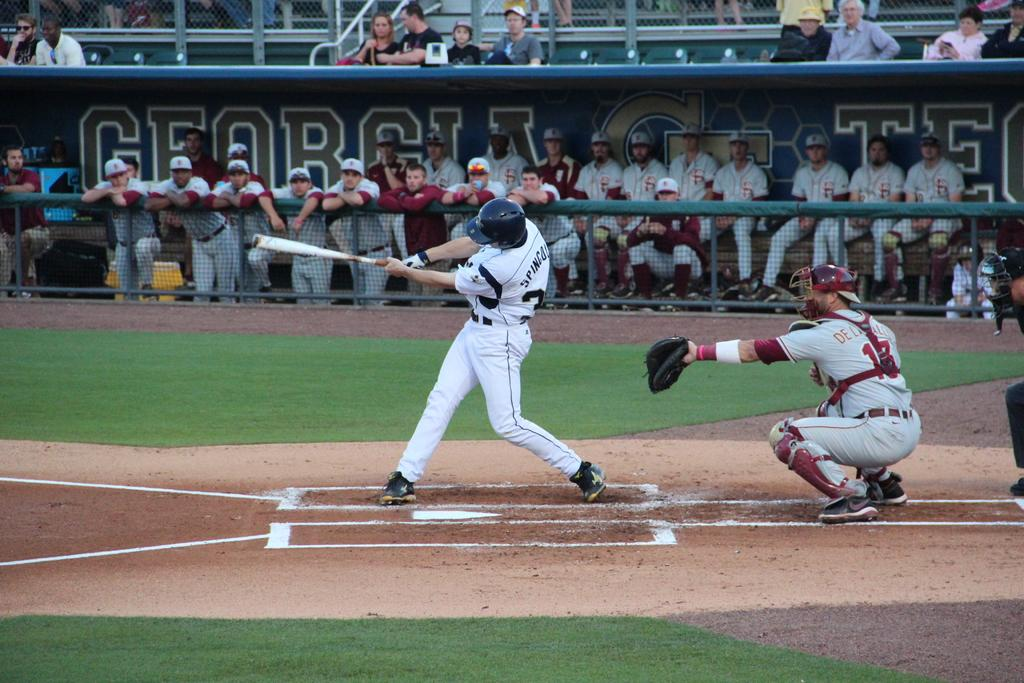Provide a one-sentence caption for the provided image. players in the georgia tech dugout watching the hitter. 